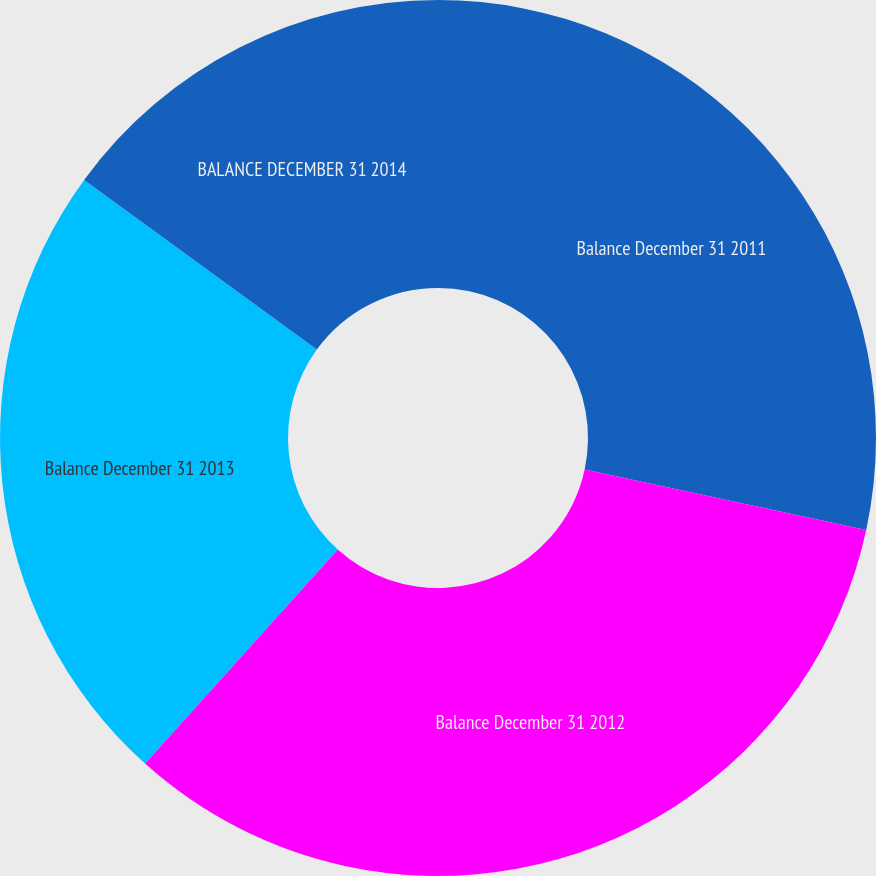<chart> <loc_0><loc_0><loc_500><loc_500><pie_chart><fcel>Balance December 31 2011<fcel>Balance December 31 2012<fcel>Balance December 31 2013<fcel>BALANCE DECEMBER 31 2014<nl><fcel>28.37%<fcel>33.29%<fcel>23.37%<fcel>14.97%<nl></chart> 